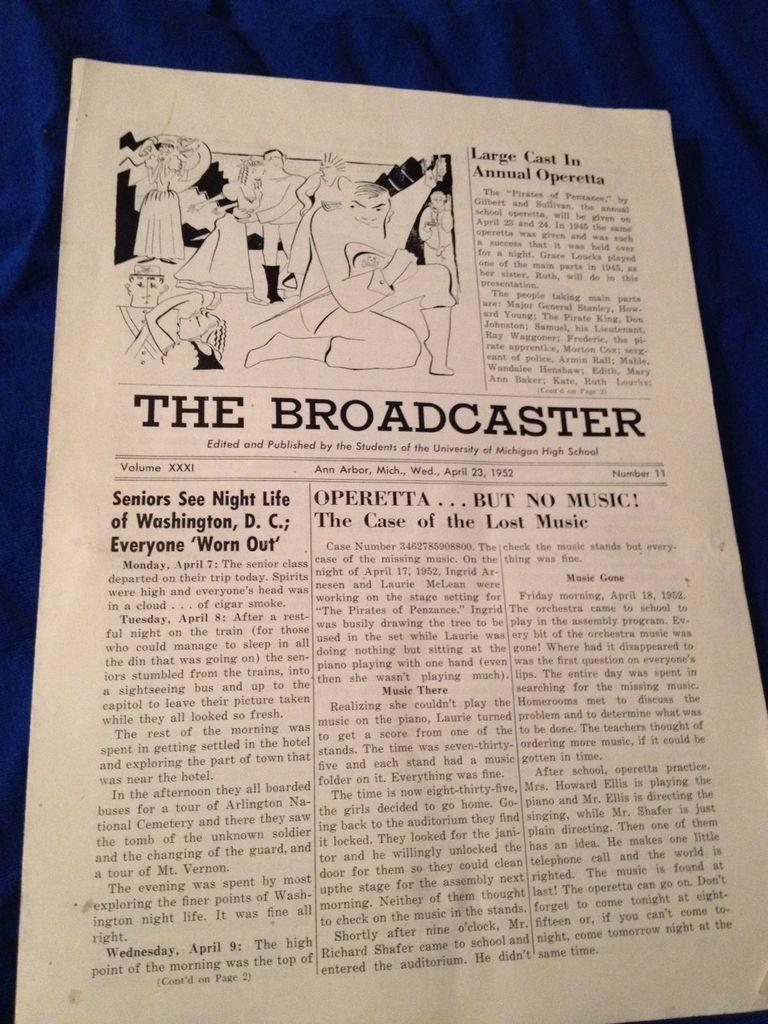<image>
Give a short and clear explanation of the subsequent image. A school newspaper from a Michigan high school is named The Broadcaster. 